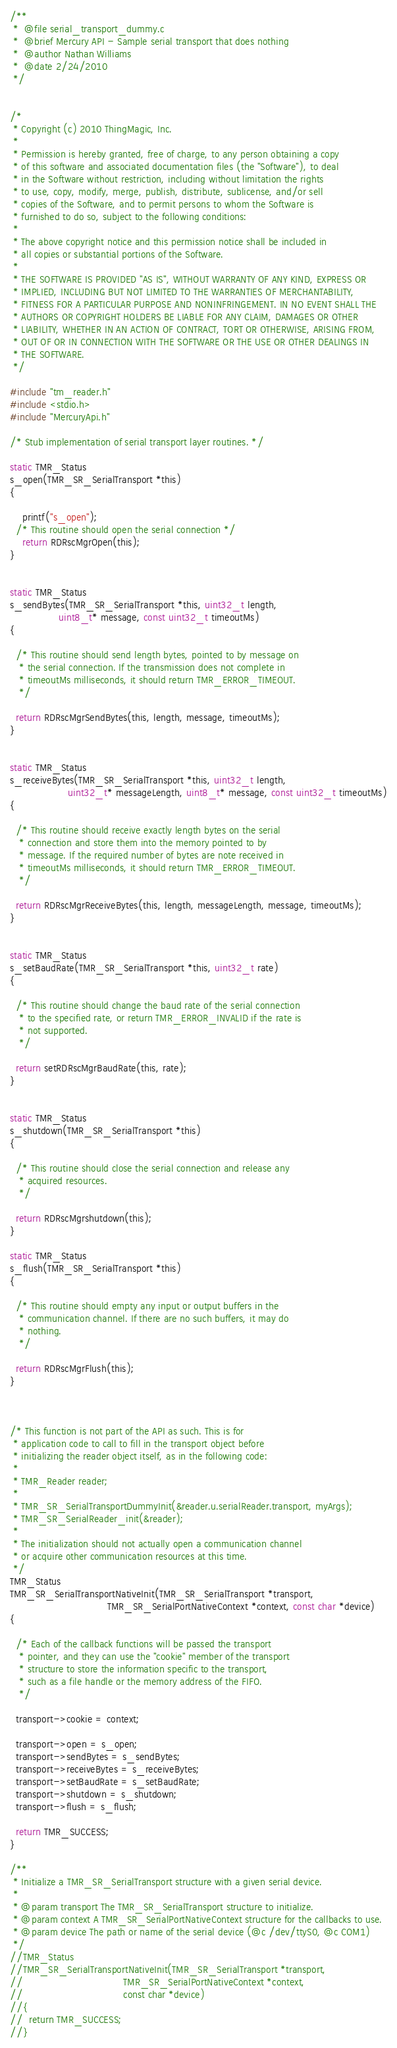Convert code to text. <code><loc_0><loc_0><loc_500><loc_500><_C_>/**
 *  @file serial_transport_dummy.c
 *  @brief Mercury API - Sample serial transport that does nothing
 *  @author Nathan Williams
 *  @date 2/24/2010
 */


/*
 * Copyright (c) 2010 ThingMagic, Inc.
 *
 * Permission is hereby granted, free of charge, to any person obtaining a copy
 * of this software and associated documentation files (the "Software"), to deal
 * in the Software without restriction, including without limitation the rights
 * to use, copy, modify, merge, publish, distribute, sublicense, and/or sell
 * copies of the Software, and to permit persons to whom the Software is
 * furnished to do so, subject to the following conditions:
 *
 * The above copyright notice and this permission notice shall be included in
 * all copies or substantial portions of the Software.
 * 
 * THE SOFTWARE IS PROVIDED "AS IS", WITHOUT WARRANTY OF ANY KIND, EXPRESS OR
 * IMPLIED, INCLUDING BUT NOT LIMITED TO THE WARRANTIES OF MERCHANTABILITY,
 * FITNESS FOR A PARTICULAR PURPOSE AND NONINFRINGEMENT. IN NO EVENT SHALL THE
 * AUTHORS OR COPYRIGHT HOLDERS BE LIABLE FOR ANY CLAIM, DAMAGES OR OTHER
 * LIABILITY, WHETHER IN AN ACTION OF CONTRACT, TORT OR OTHERWISE, ARISING FROM,
 * OUT OF OR IN CONNECTION WITH THE SOFTWARE OR THE USE OR OTHER DEALINGS IN
 * THE SOFTWARE.
 */

#include "tm_reader.h"
#include <stdio.h>
#include "MercuryApi.h"

/* Stub implementation of serial transport layer routines. */

static TMR_Status
s_open(TMR_SR_SerialTransport *this)
{

    printf("s_open");
  /* This routine should open the serial connection */
    return RDRscMgrOpen(this);
}


static TMR_Status
s_sendBytes(TMR_SR_SerialTransport *this, uint32_t length, 
                uint8_t* message, const uint32_t timeoutMs)
{

  /* This routine should send length bytes, pointed to by message on
   * the serial connection. If the transmission does not complete in
   * timeoutMs milliseconds, it should return TMR_ERROR_TIMEOUT.
   */

  return RDRscMgrSendBytes(this, length, message, timeoutMs);
}


static TMR_Status
s_receiveBytes(TMR_SR_SerialTransport *this, uint32_t length, 
                   uint32_t* messageLength, uint8_t* message, const uint32_t timeoutMs)
{

  /* This routine should receive exactly length bytes on the serial
   * connection and store them into the memory pointed to by
   * message. If the required number of bytes are note received in
   * timeoutMs milliseconds, it should return TMR_ERROR_TIMEOUT.
   */

  return RDRscMgrReceiveBytes(this, length, messageLength, message, timeoutMs);
}


static TMR_Status
s_setBaudRate(TMR_SR_SerialTransport *this, uint32_t rate)
{

  /* This routine should change the baud rate of the serial connection
   * to the specified rate, or return TMR_ERROR_INVALID if the rate is
   * not supported.
   */

  return setRDRscMgrBaudRate(this, rate);
}


static TMR_Status
s_shutdown(TMR_SR_SerialTransport *this)
{

  /* This routine should close the serial connection and release any
   * acquired resources.
   */

  return RDRscMgrshutdown(this);
}

static TMR_Status
s_flush(TMR_SR_SerialTransport *this)
{

  /* This routine should empty any input or output buffers in the
   * communication channel. If there are no such buffers, it may do
   * nothing.
   */

  return RDRscMgrFlush(this);
}



/* This function is not part of the API as such. This is for
 * application code to call to fill in the transport object before
 * initializing the reader object itself, as in the following code:
 * 
 * TMR_Reader reader;
 *
 * TMR_SR_SerialTransportDummyInit(&reader.u.serialReader.transport, myArgs);
 * TMR_SR_SerialReader_init(&reader);
 *
 * The initialization should not actually open a communication channel
 * or acquire other communication resources at this time.
 */
TMR_Status
TMR_SR_SerialTransportNativeInit(TMR_SR_SerialTransport *transport,
								TMR_SR_SerialPortNativeContext *context, const char *device)
{

  /* Each of the callback functions will be passed the transport
   * pointer, and they can use the "cookie" member of the transport
   * structure to store the information specific to the transport,
   * such as a file handle or the memory address of the FIFO.
   */
    
  transport->cookie = context;

  transport->open = s_open;
  transport->sendBytes = s_sendBytes;
  transport->receiveBytes = s_receiveBytes;
  transport->setBaudRate = s_setBaudRate;
  transport->shutdown = s_shutdown;
  transport->flush = s_flush;

  return TMR_SUCCESS;
}

/**
 * Initialize a TMR_SR_SerialTransport structure with a given serial device.
 *
 * @param transport The TMR_SR_SerialTransport structure to initialize.
 * @param context A TMR_SR_SerialPortNativeContext structure for the callbacks to use.
 * @param device The path or name of the serial device (@c /dev/ttyS0, @c COM1)
 */
//TMR_Status
//TMR_SR_SerialTransportNativeInit(TMR_SR_SerialTransport *transport,
//                                 TMR_SR_SerialPortNativeContext *context,
//                                 const char *device)
//{
//  return TMR_SUCCESS;
//}

</code> 